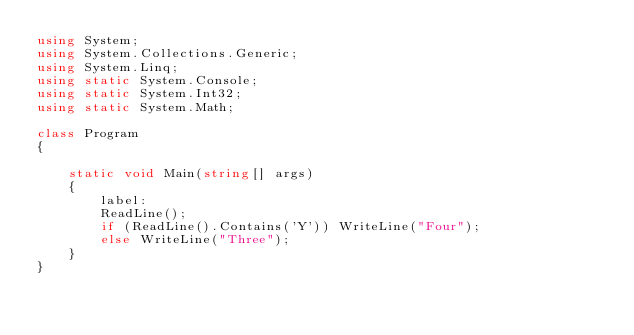<code> <loc_0><loc_0><loc_500><loc_500><_C#_>using System;
using System.Collections.Generic;
using System.Linq;
using static System.Console;
using static System.Int32;
using static System.Math;

class Program
{

    static void Main(string[] args)
    {
        label:
        ReadLine();
        if (ReadLine().Contains('Y')) WriteLine("Four");
        else WriteLine("Three");
    }
}
</code> 